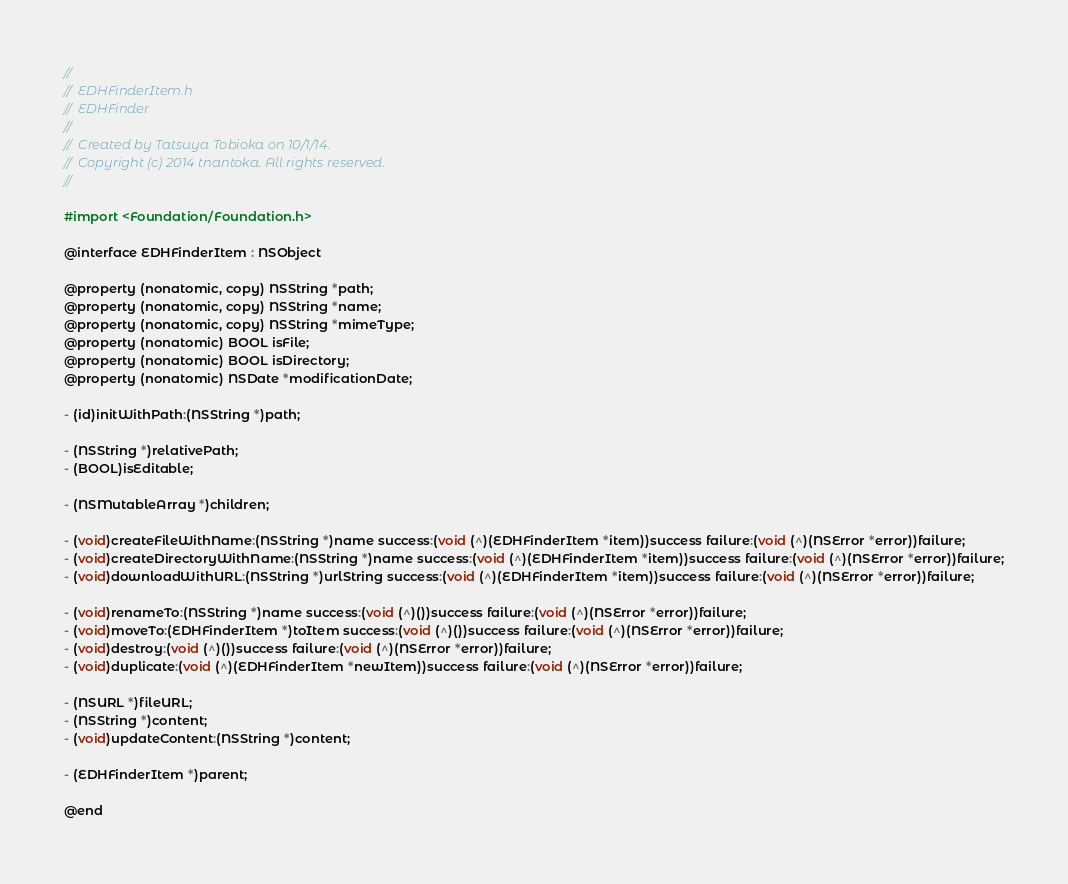<code> <loc_0><loc_0><loc_500><loc_500><_C_>//
//  EDHFinderItem.h
//  EDHFinder
//
//  Created by Tatsuya Tobioka on 10/1/14.
//  Copyright (c) 2014 tnantoka. All rights reserved.
//

#import <Foundation/Foundation.h>

@interface EDHFinderItem : NSObject

@property (nonatomic, copy) NSString *path;
@property (nonatomic, copy) NSString *name;
@property (nonatomic, copy) NSString *mimeType;
@property (nonatomic) BOOL isFile;
@property (nonatomic) BOOL isDirectory;
@property (nonatomic) NSDate *modificationDate;

- (id)initWithPath:(NSString *)path;

- (NSString *)relativePath;
- (BOOL)isEditable;

- (NSMutableArray *)children;

- (void)createFileWithName:(NSString *)name success:(void (^)(EDHFinderItem *item))success failure:(void (^)(NSError *error))failure;
- (void)createDirectoryWithName:(NSString *)name success:(void (^)(EDHFinderItem *item))success failure:(void (^)(NSError *error))failure;
- (void)downloadWithURL:(NSString *)urlString success:(void (^)(EDHFinderItem *item))success failure:(void (^)(NSError *error))failure;

- (void)renameTo:(NSString *)name success:(void (^)())success failure:(void (^)(NSError *error))failure;
- (void)moveTo:(EDHFinderItem *)toItem success:(void (^)())success failure:(void (^)(NSError *error))failure;
- (void)destroy:(void (^)())success failure:(void (^)(NSError *error))failure;
- (void)duplicate:(void (^)(EDHFinderItem *newItem))success failure:(void (^)(NSError *error))failure;

- (NSURL *)fileURL;
- (NSString *)content;
- (void)updateContent:(NSString *)content;

- (EDHFinderItem *)parent;

@end
</code> 